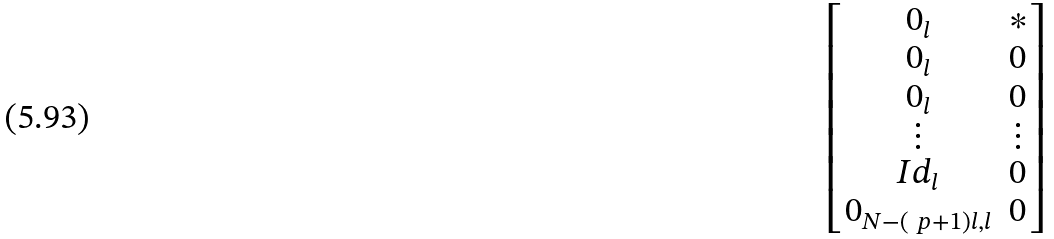Convert formula to latex. <formula><loc_0><loc_0><loc_500><loc_500>\begin{bmatrix} 0 _ { l } & * \\ 0 _ { l } & 0 \\ 0 _ { l } & 0 \\ \vdots & \vdots \\ I d _ { l } & 0 \\ 0 _ { N - ( \ p + 1 ) l , l } & 0 \end{bmatrix}</formula> 